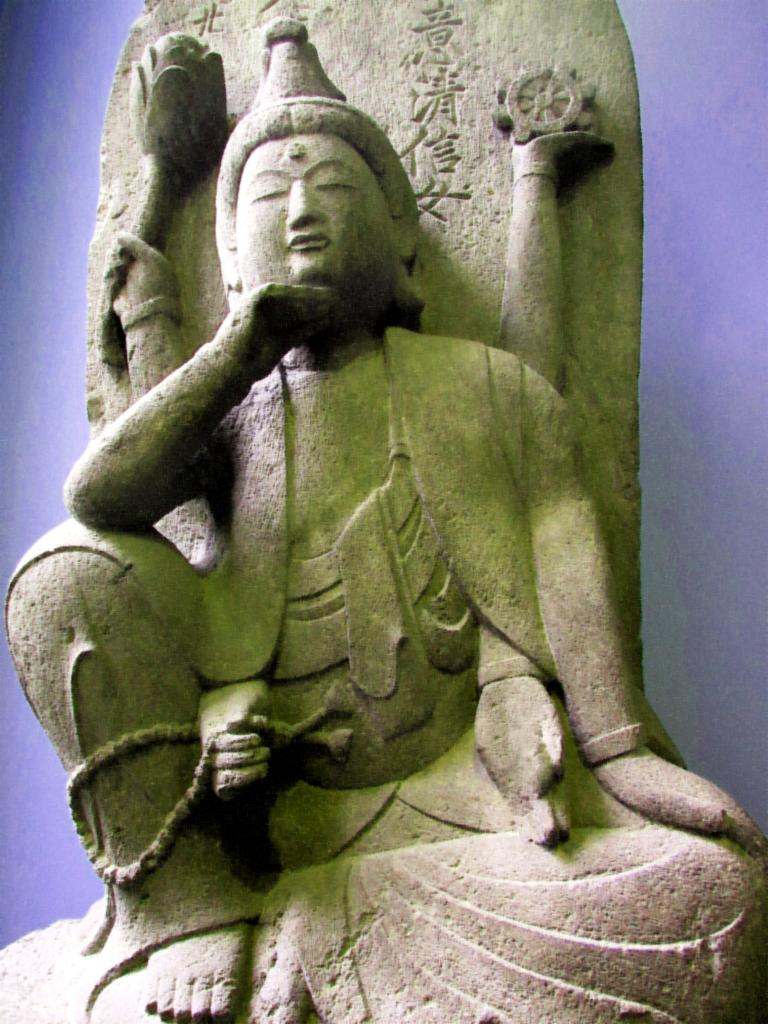What is the main subject of the image? There is a statue of a person in the image. Where is the statue located? The statue is on a platform. What can be seen in the background of the image? There is a blue color wall in the background of the image. What type of joke is being told by the statue in the image? There is no joke being told by the statue in the image, as it is a statue and not a living person. 